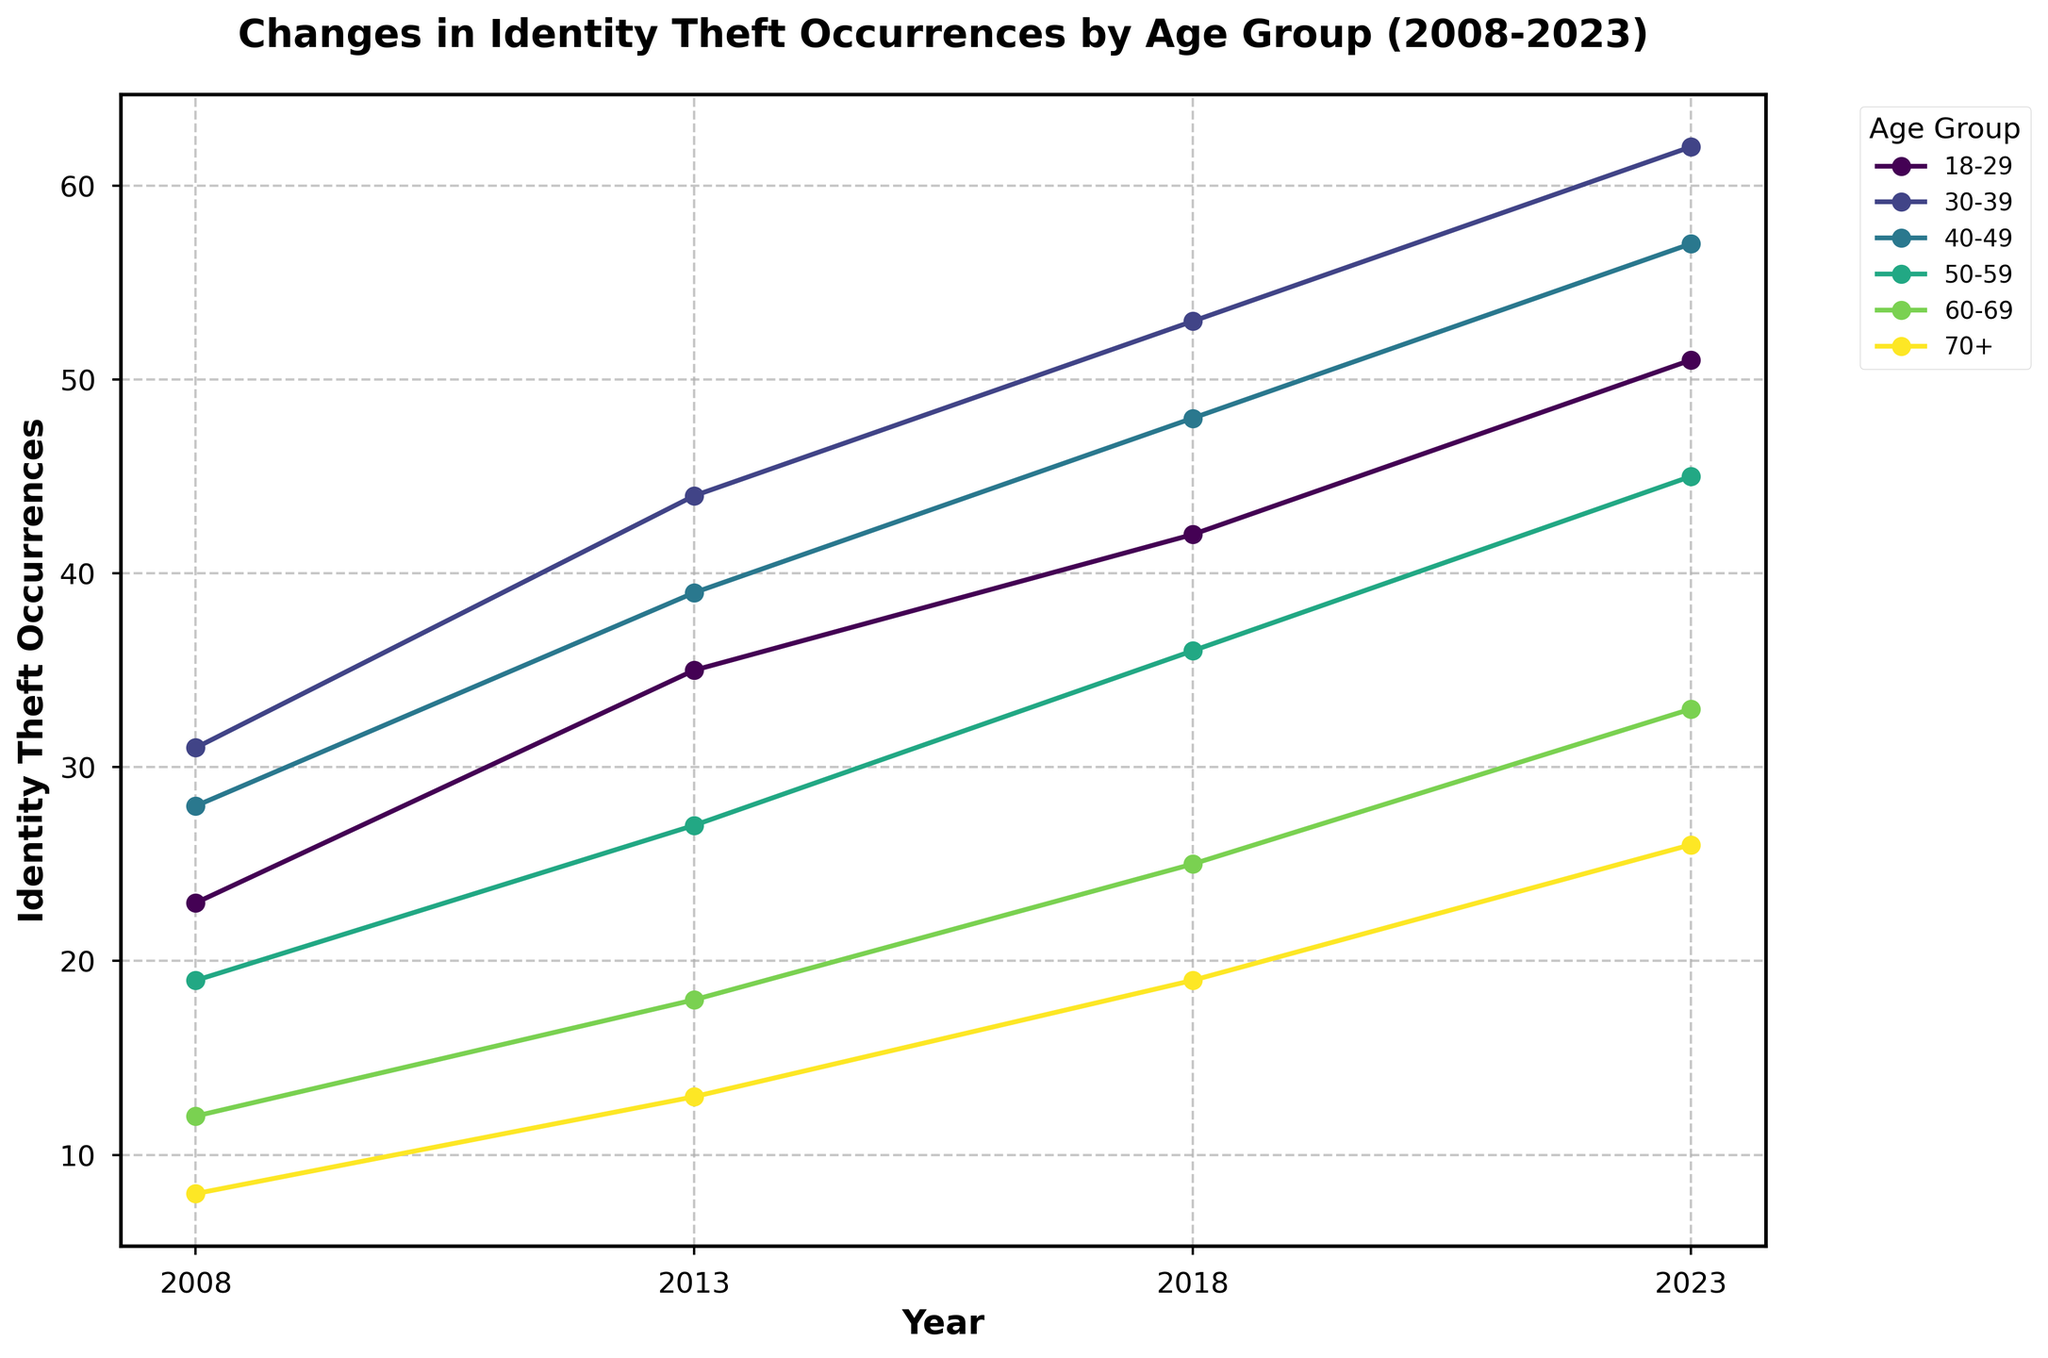What's the highest number of identity theft occurrences among all age groups in 2023? Look at the data point for each age group in 2023 and identify the highest value, which is 62 for the 30-39 age group.
Answer: 62 Which age group had the smallest increase in identity theft occurrences from 2008 to 2023? Calculate the increase for each age group from 2008 to 2023: 18-29 (51-23=28), 30-39 (62-31=31), 40-49 (57-28=29), 50-59 (45-19=26), 60-69 (33-12=21), 70+ (26-8=18). The smallest increase is 18 for the 70+ age group.
Answer: 70+ How did the occurrence of identity theft change for the 50-59 age group between 2008 and 2013? Subtract the 2008 value for the 50-59 age group from the 2013 value: 27 - 19 = 8.
Answer: It increased by 8 Which age group showed a higher increase in identity theft occurrences from 2008 to 2023, 30-39 or 40-49? Calculate the increase for each age group: 30-39 (62-31=31), 40-49 (57-28=29). The 30-39 age group had a higher increase (31 > 29).
Answer: 30-39 What's the average number of identity theft occurrences in 2023 across all age groups? Sum the occurrences of identity theft for all age groups in 2023 and divide by the number of age groups: (51+62+57+45+33+26)/6 = 274/6 ≈ 45.67.
Answer: 45.67 Which age group had the steepest rise in identity theft occurrences between any two consecutive years? Compare the changes between consecutive years for each age group: the steepest rise is from 2018 to 2023 for the 30-39 age group (62-53=9).
Answer: 30-39 In which year was the identity theft occurrences for the 70+ age group closest to the occurrences for the 18-29 age group? Comparing the data: 2008 (23 vs 8), 2013 (35 vs 13), 2018 (42 vs 19), 2023 (51 vs 26). The difference is smallest in 2023 where it is 51-26=25.
Answer: 2023 What is the total increase in identity theft occurrences for the 60-69 age group from 2008 to 2023? Subtract the 2008 value from the 2023 value for the 60-69 age group (33-12=21).
Answer: 21 